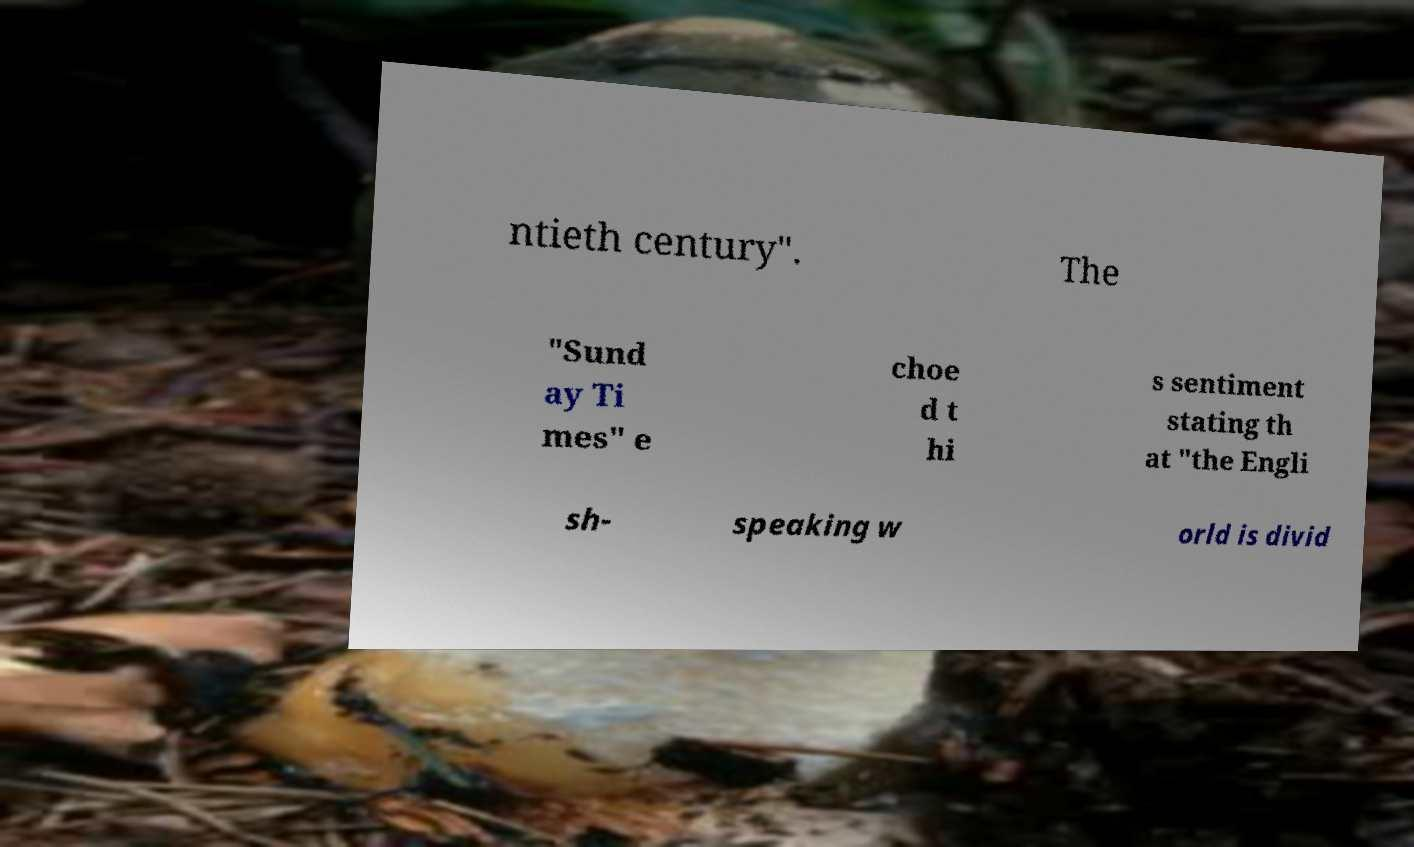Can you read and provide the text displayed in the image?This photo seems to have some interesting text. Can you extract and type it out for me? ntieth century". The "Sund ay Ti mes" e choe d t hi s sentiment stating th at "the Engli sh- speaking w orld is divid 